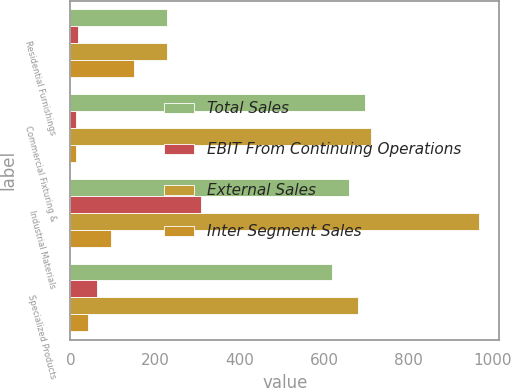Convert chart to OTSL. <chart><loc_0><loc_0><loc_500><loc_500><stacked_bar_chart><ecel><fcel>Residential Furnishings<fcel>Commercial Fixturing &<fcel>Industrial Materials<fcel>Specialized Products<nl><fcel>Total Sales<fcel>229.35<fcel>696.9<fcel>658.2<fcel>618.7<nl><fcel>EBIT From Continuing Operations<fcel>17.5<fcel>14.4<fcel>308<fcel>63<nl><fcel>External Sales<fcel>229.35<fcel>711.3<fcel>966.2<fcel>681.7<nl><fcel>Inter Segment Sales<fcel>150.7<fcel>13.8<fcel>95.5<fcel>40.7<nl></chart> 